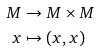<formula> <loc_0><loc_0><loc_500><loc_500>M & \to M \times M \\ x & \mapsto ( x , x )</formula> 